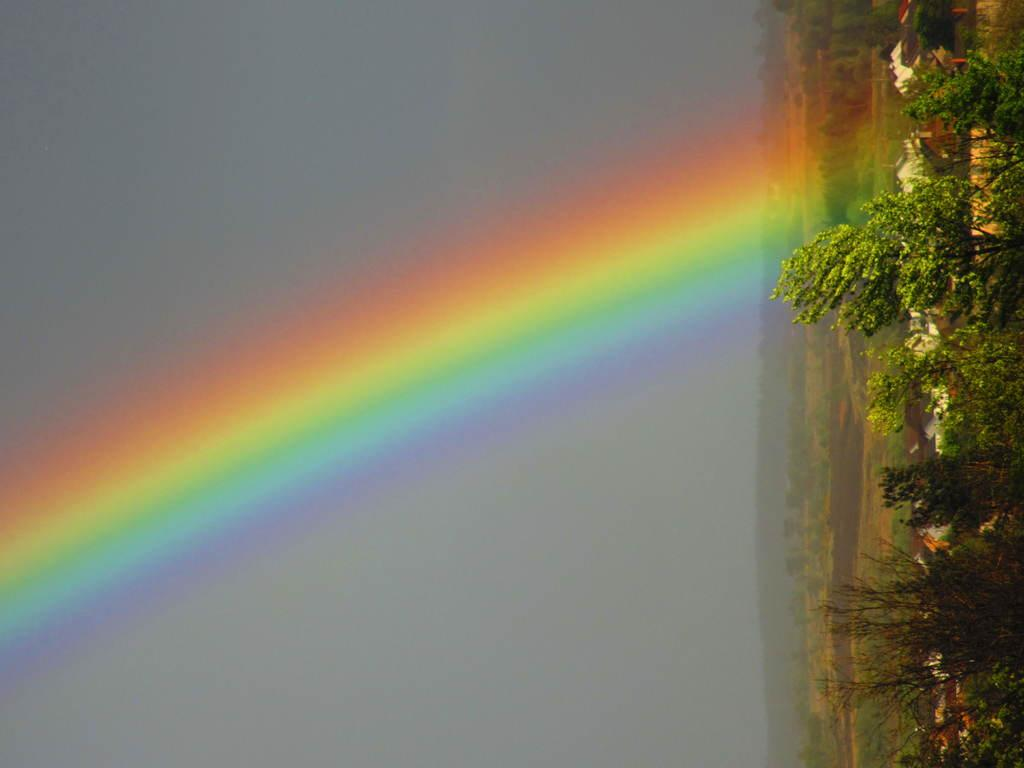What type of vegetation is on the right side of the image? There are plants on the right side of the image. What natural phenomenon can be seen in the middle of the image? There is a rainbow in the middle of the image. What is visible at the top of the image? The sky is visible at the top of the image. What type of structures are on the right side top of the image? There are houses on the right side top of the image. How is the image oriented? The image is vertical in orientation. What type of caption is written on the rainbow in the image? There is no caption written on the rainbow in the image. Can you tell me how many insects are crawling on the plants in the image? There are no insects visible on the plants in the image. 